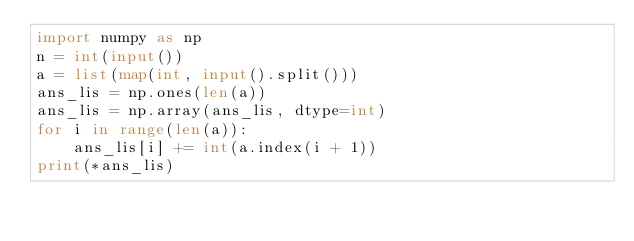Convert code to text. <code><loc_0><loc_0><loc_500><loc_500><_Python_>import numpy as np
n = int(input())
a = list(map(int, input().split()))
ans_lis = np.ones(len(a))
ans_lis = np.array(ans_lis, dtype=int)
for i in range(len(a)):
    ans_lis[i] += int(a.index(i + 1))
print(*ans_lis)
</code> 